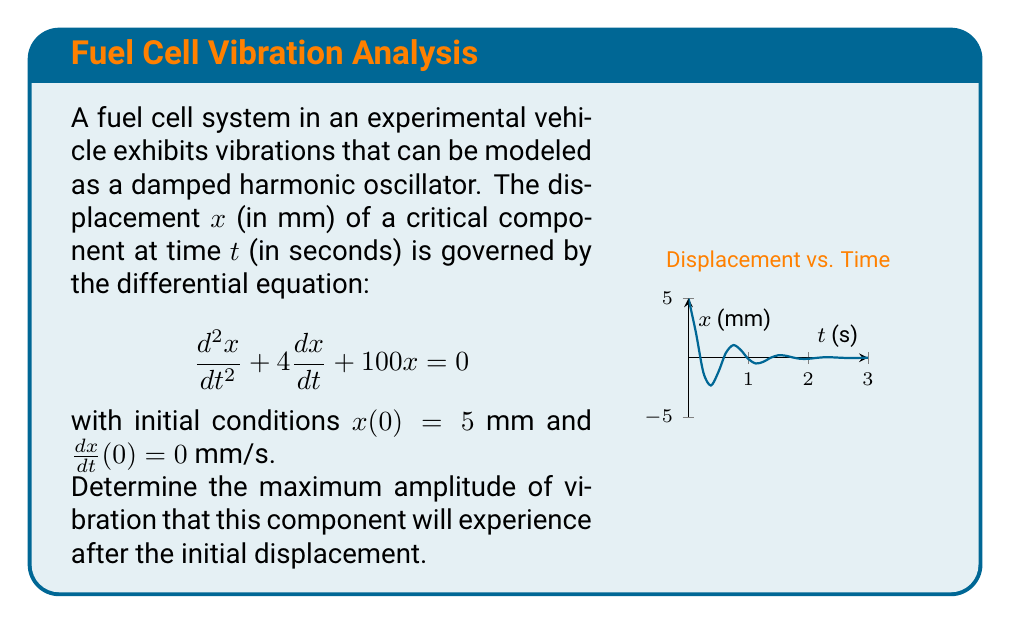Give your solution to this math problem. To solve this problem, we follow these steps:

1) The given differential equation is in the form of a damped harmonic oscillator:
   $$\frac{d^2x}{dt^2} + 2\beta\frac{dx}{dt} + \omega_0^2x = 0$$
   where $2\beta = 4$ and $\omega_0^2 = 100$.

2) Calculate $\beta$ and $\omega_0$:
   $\beta = 2$ and $\omega_0 = 10$

3) Determine if the system is underdamped, critically damped, or overdamped:
   The system is underdamped if $\beta < \omega_0$, which is true here (2 < 10).

4) For underdamped systems, the solution has the form:
   $$x(t) = Ae^{-\beta t}\cos(\omega t - \phi)$$
   where $\omega = \sqrt{\omega_0^2 - \beta^2} = \sqrt{100 - 4} = \sqrt{96} = 4\sqrt{6}$

5) The amplitude $A$ and phase $\phi$ are determined by initial conditions, but we don't need to calculate them for this question.

6) The maximum amplitude after the initial displacement will occur when $\cos(\omega t - \phi) = \pm 1$, i.e., at the peaks of the cosine function.

7) The exponential decay factor $e^{-\beta t}$ causes the amplitude to decrease over time.

8) Therefore, the maximum amplitude after the initial displacement will be the amplitude at $t = 0$, which is given in the initial conditions as 5 mm.
Answer: 5 mm 